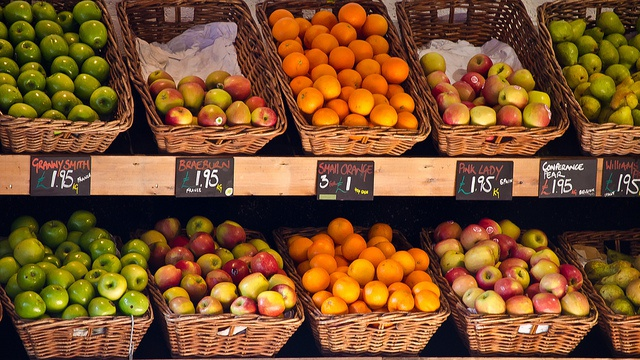Describe the objects in this image and their specific colors. I can see apple in black and olive tones, orange in black, red, brown, orange, and maroon tones, apple in black and olive tones, apple in black, maroon, olive, and orange tones, and apple in black, orange, brown, and maroon tones in this image. 